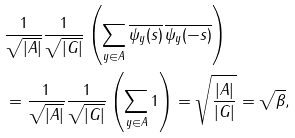<formula> <loc_0><loc_0><loc_500><loc_500>& \frac { 1 } { \sqrt { | A | } } \frac { 1 } { \sqrt { | G | } } \left ( \sum _ { y \in A } \overline { \psi _ { y } ( s ) } \, \overline { \psi _ { y } ( - s ) } \right ) \\ & = \frac { 1 } { \sqrt { | A | } } \frac { 1 } { \sqrt { | G | } } \left ( \sum _ { y \in A } 1 \right ) = \sqrt { \frac { | A | } { | G | } } = \sqrt { \beta } ,</formula> 